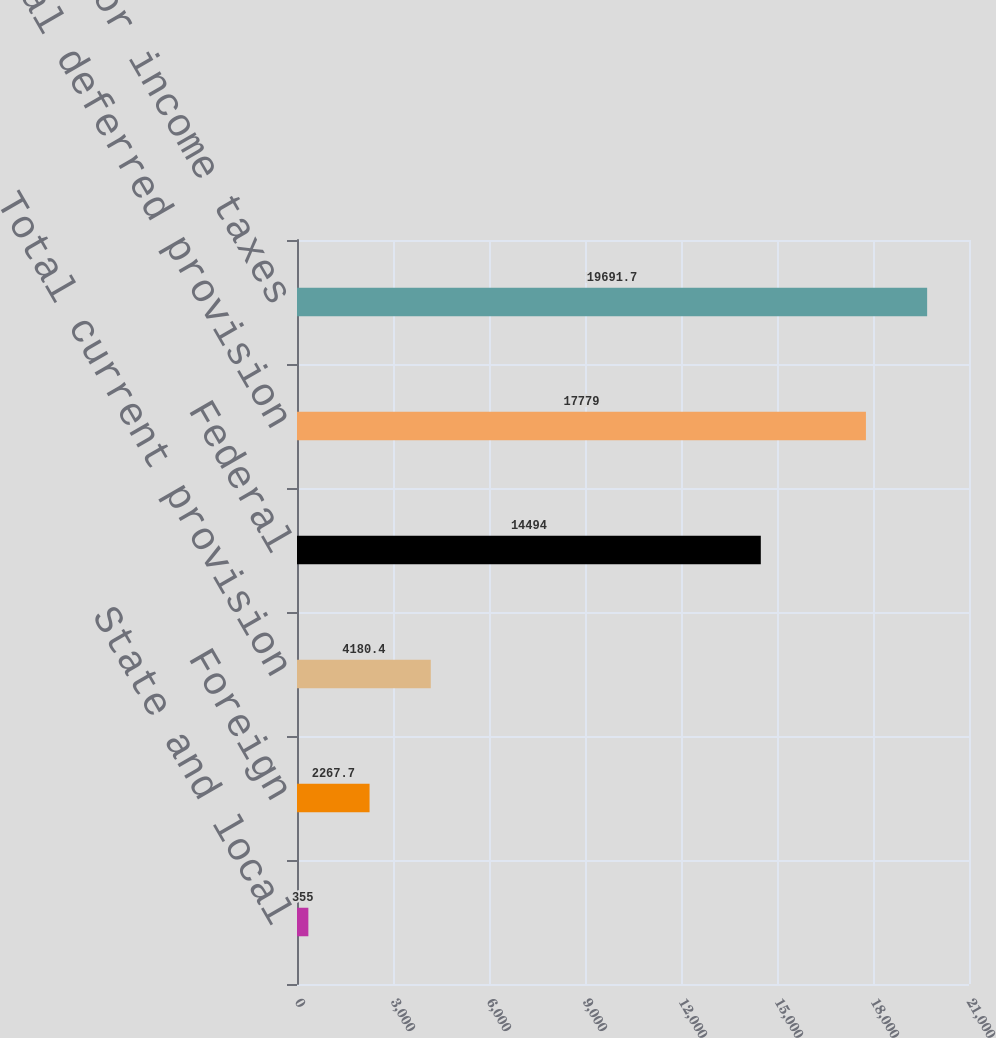<chart> <loc_0><loc_0><loc_500><loc_500><bar_chart><fcel>State and local<fcel>Foreign<fcel>Total current provision<fcel>Federal<fcel>Total deferred provision<fcel>Provision for income taxes<nl><fcel>355<fcel>2267.7<fcel>4180.4<fcel>14494<fcel>17779<fcel>19691.7<nl></chart> 